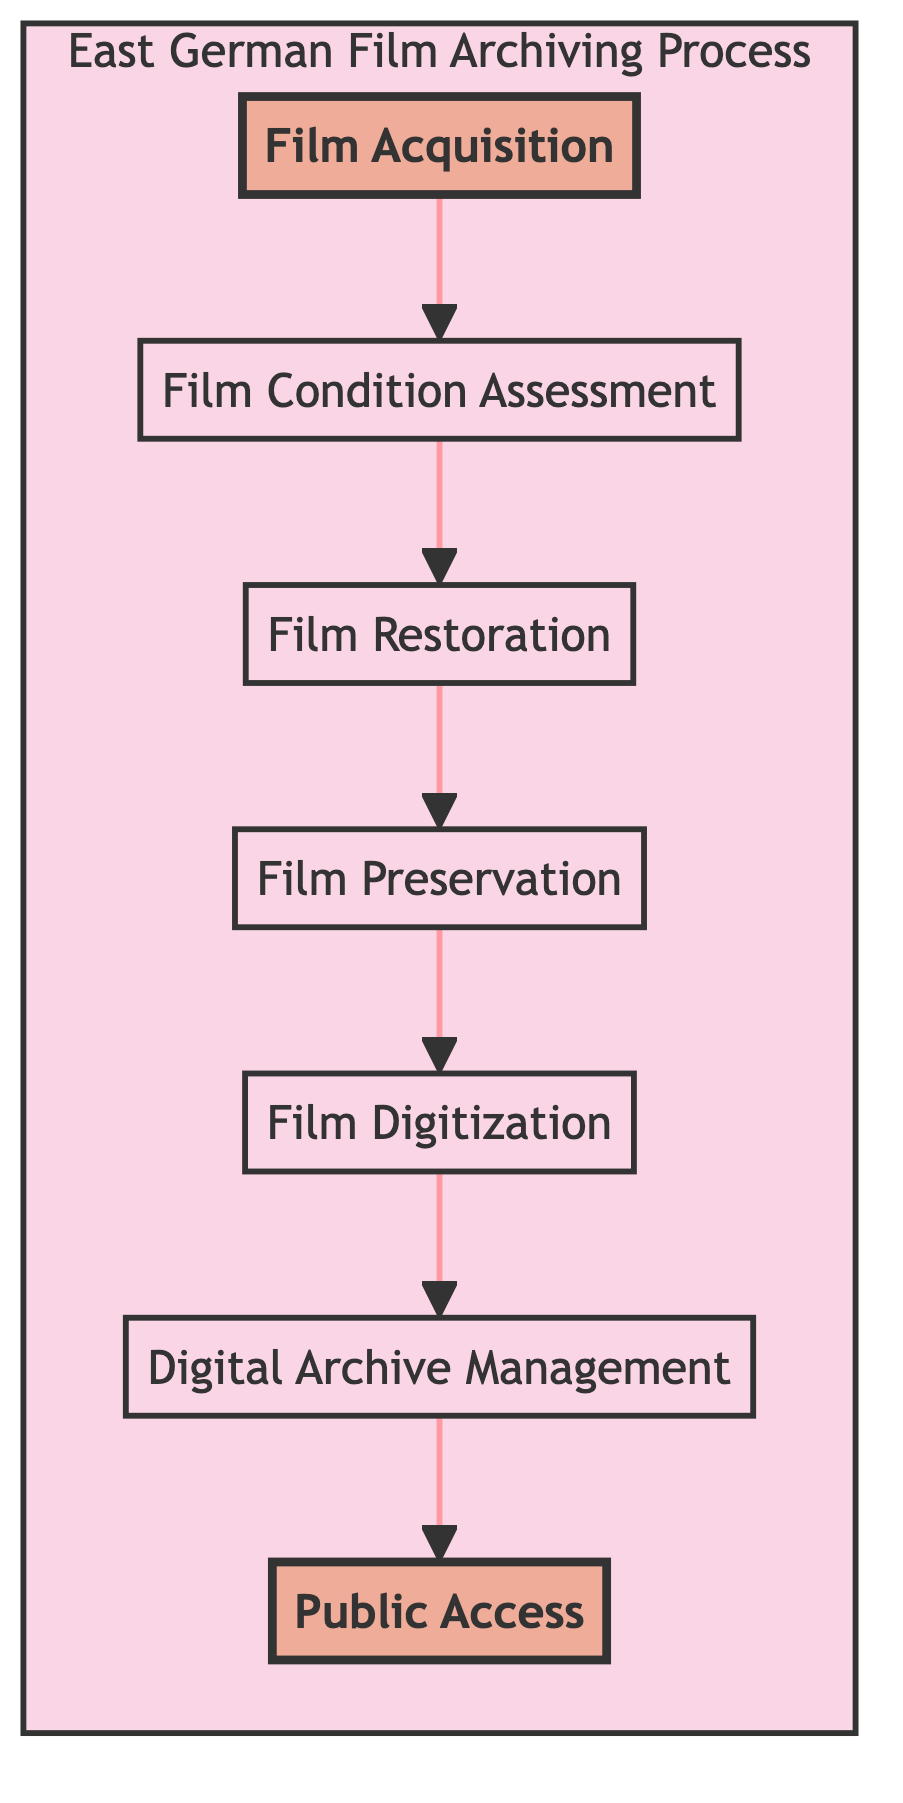What is the starting step in the East German Film Archiving Process? The starting step is shown at the bottom of the diagram, which is "Film Acquisition". This step indicates where the process begins, gathering films from various sources.
Answer: Film Acquisition What is the last step in the East German Film Archiving Process? The last step is "Public Access", located at the top of the diagram. This step depicts the final goal of making the digital films available for viewing and research.
Answer: Public Access How many steps are there in the East German Film Archiving Process? By counting the nodes in the diagram from "Film Acquisition" to "Public Access", there are a total of seven steps in this archiving process.
Answer: 7 What follows "Film Preservation" in the process? The step that directly follows "Film Preservation" is "Film Digitization". This shows the progression from preserving the physical film to converting it into a digital format.
Answer: Film Digitization Which step involves evaluating the state of film reels? In the diagram, "Film Condition Assessment" is the step dedicated to evaluating the state of film reels, including checking for damages.
Answer: Film Condition Assessment What is the relationship between "Film Restoration" and "Film Preservation"? "Film Restoration" precedes "Film Preservation"; the diagram shows a directed connection from "Film Restoration" to "Film Preservation", indicating that restoration must occur before preservation can take place.
Answer: Precedes How does the archiving process ensure the longevity of films? The process ensures longevity through the "Film Preservation" step, where restored films are stored in climate-controlled conditions to prevent deterioration.
Answer: Climate-controlled archives Which step is highlighted in the diagram? The two highlighted steps in the diagram are "Film Acquisition" and "Public Access", indicating their significance as starting and ending points of the archiving process.
Answer: Film Acquisition and Public Access What type of system is used for organizing digital films? The step "Digital Archive Management" involves organizing and cataloging the digital films in a digital asset management system to ensure they are accessible.
Answer: Digital asset management system What is the purpose of the "Film Digitization" step? The purpose of "Film Digitization" is to convert the restored films into digital formats using high-resolution scanners to create digital master copies.
Answer: Convert to digital formats 